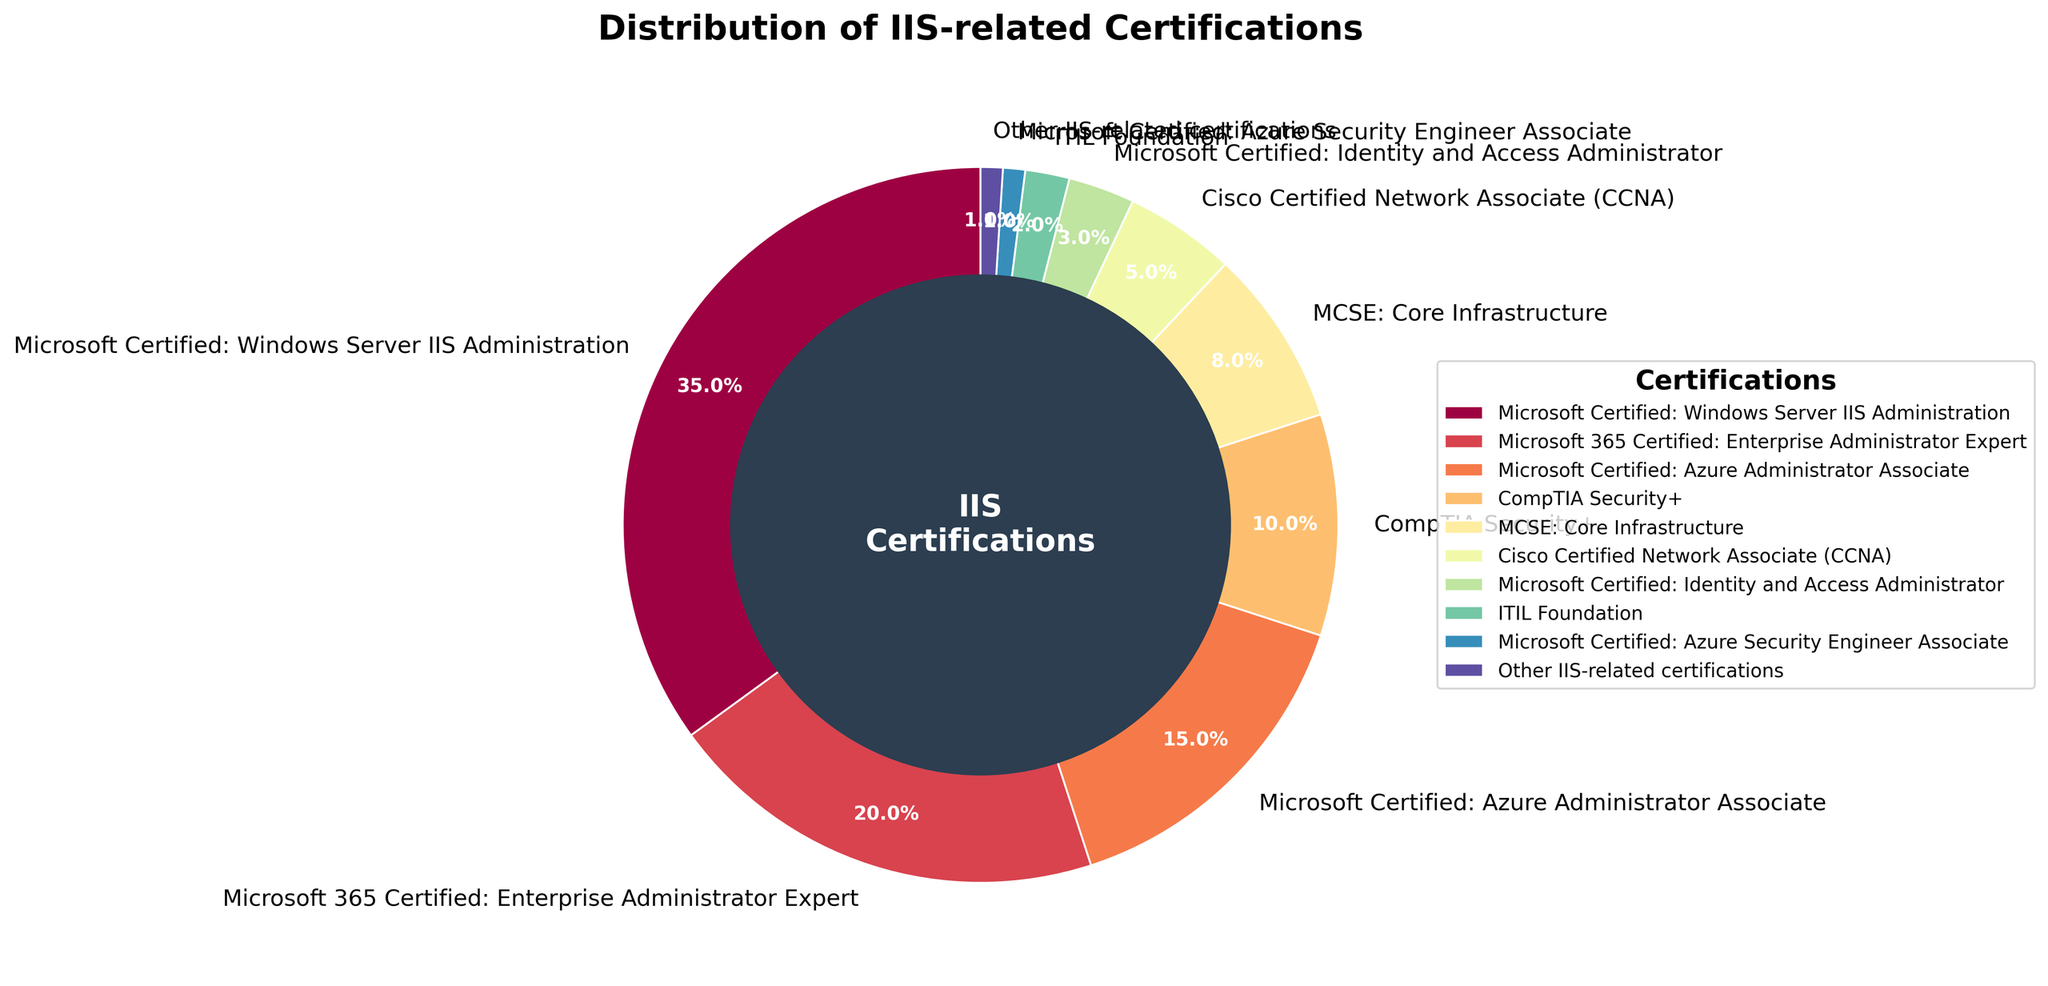How many types of certifications are represented in the pie chart? Count all the unique labels in the pie chart. The list includes: "Microsoft Certified: Windows Server IIS Administration," "Microsoft 365 Certified: Enterprise Administrator Expert," "Microsoft Certified: Azure Administrator Associate," "CompTIA Security+," "MCSE: Core Infrastructure," "Cisco Certified Network Associate (CCNA)," "Microsoft Certified: Identity and Access Administrator," "ITIL Foundation," "Microsoft Certified: Azure Security Engineer Associate," and "Other IIS-related certifications." This results in 10 types of certifications.
Answer: 10 Which certification holds the largest percentage of IIS-related certifications among IT professionals? Identify the wedge with the largest visible portion. Based on the data, "Microsoft Certified: Windows Server IIS Administration" has the largest percentage at 35%.
Answer: Microsoft Certified: Windows Server IIS Administration What is the combined percentage of Microsoft-related certifications? Add the percentages of: "Microsoft Certified: Windows Server IIS Administration" (35%), "Microsoft 365 Certified: Enterprise Administrator Expert" (20%), "Microsoft Certified: Azure Administrator Associate" (15%), "Microsoft Certified: Identity and Access Administrator" (3%), and "Microsoft Certified: Azure Security Engineer Associate" (1%). The sum is 35 + 20 + 15 + 3 + 1 = 74%.
Answer: 74% Which certification category has a smaller percentage, CompTIA Security+ or MCSE: Core Infrastructure? Compare the percentages of "CompTIA Security+" (10%) and "MCSE: Core Infrastructure" (8%). "MCSE: Core Infrastructure" has the smaller percentage.
Answer: MCSE: Core Infrastructure Are there any certifications that have approximately the same percentage close to 1%? Look at the percentages of all certifications. "Microsoft Certified: Azure Security Engineer Associate" and "Other IIS-related certifications" both have a percentage close to 1%.
Answer: Yes Which certification appears next to the "ITIL Foundation" certification in the pie chart? Visually identify the section beside the "ITIL Foundation" label. "Other IIS-related certifications" appears next to the "ITIL Foundation" certification.
Answer: Other IIS-related certifications How does the percentage of Microsoft 365 Certified: Enterprise Administrator Expert compare to the combination of ITIL Foundation, Microsoft Certified: Azure Security Engineer Associate, and Other IIS-related certifications? The percentage of "Microsoft 365 Certified: Enterprise Administrator Expert" is 20%. Add the percentages of "ITIL Foundation" (2%), "Microsoft Certified: Azure Security Engineer Associate" (1%), and "Other IIS-related certifications" (1%). Their sum is 2 + 1 + 1 = 4%. Compare the two and see that 20% is much greater than 4%.
Answer: Much greater What portion of the chart does Cisco Certified Network Associate (CCNA) occupy in terms of percentage? Identify the percentage associated with "Cisco Certified Network Associate (CCNA)." The data gives 5%.
Answer: 5% What is the average percentage of certifications held by categories with less than 10% representation? Identify the categories with less than 10%, which are: "MCSE: Core Infrastructure" (8%), "Cisco Certified Network Associate (CCNA)" (5%), "Microsoft Certified: Identity and Access Administrator" (3%), "ITIL Foundation" (2%), "Microsoft Certified: Azure Security Engineer Associate" (1%), and "Other IIS-related certifications" (1%). Calculate the average: (8 + 5 + 3 + 2 + 1 + 1) / 6 = 20 / 6 ≈ 3.33%.
Answer: 3.33% What certification is immediately clock-wise to "Microsoft Certified: Azure Administrator Associate"? Visually, identify the section immediately clock-wise to "Microsoft Certified: Azure Administrator Associate." "Microsoft Certified: Identity and Access Administrator" appears next.
Answer: Microsoft Certified: Identity and Access Administrator 